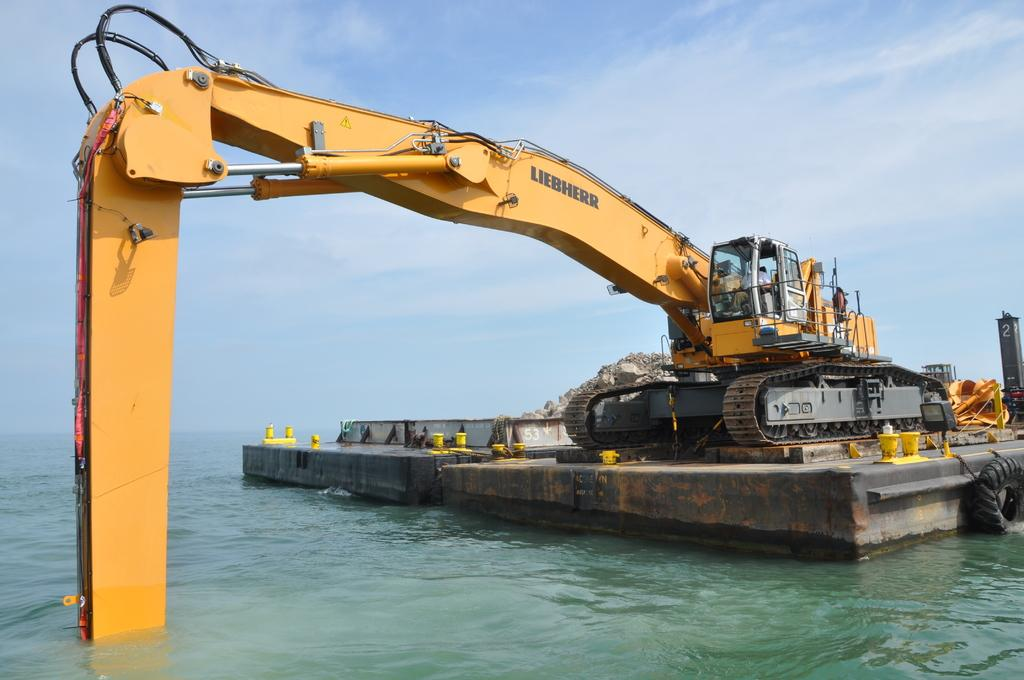What type of vehicle is on the ship in the image? There is a JCB vehicle on a ship in the image. What objects can be seen in the image besides the vehicle? There are buckets, a board, rocks, and water visible in the image. What is the background of the image? The sky is visible in the image. What type of meat is being transported by the JCB vehicle in the image? There is no meat present in the image; the JCB vehicle is on a ship with buckets, a board, rocks, and water. 